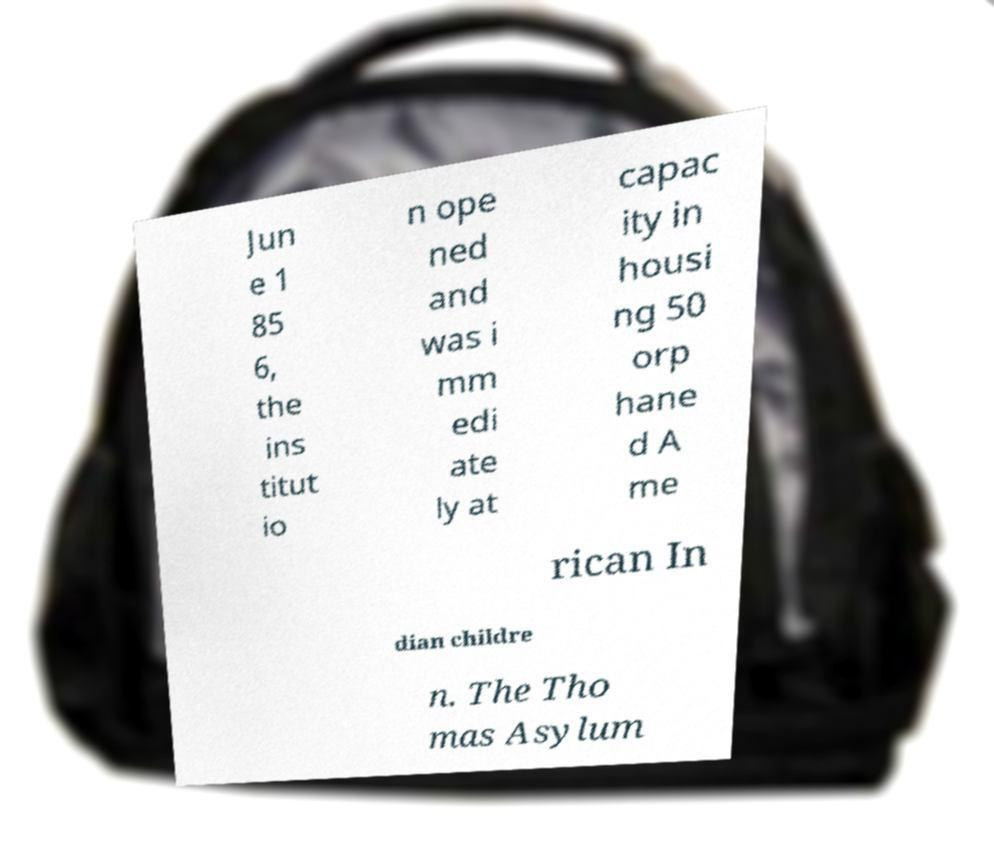Can you read and provide the text displayed in the image?This photo seems to have some interesting text. Can you extract and type it out for me? Jun e 1 85 6, the ins titut io n ope ned and was i mm edi ate ly at capac ity in housi ng 50 orp hane d A me rican In dian childre n. The Tho mas Asylum 